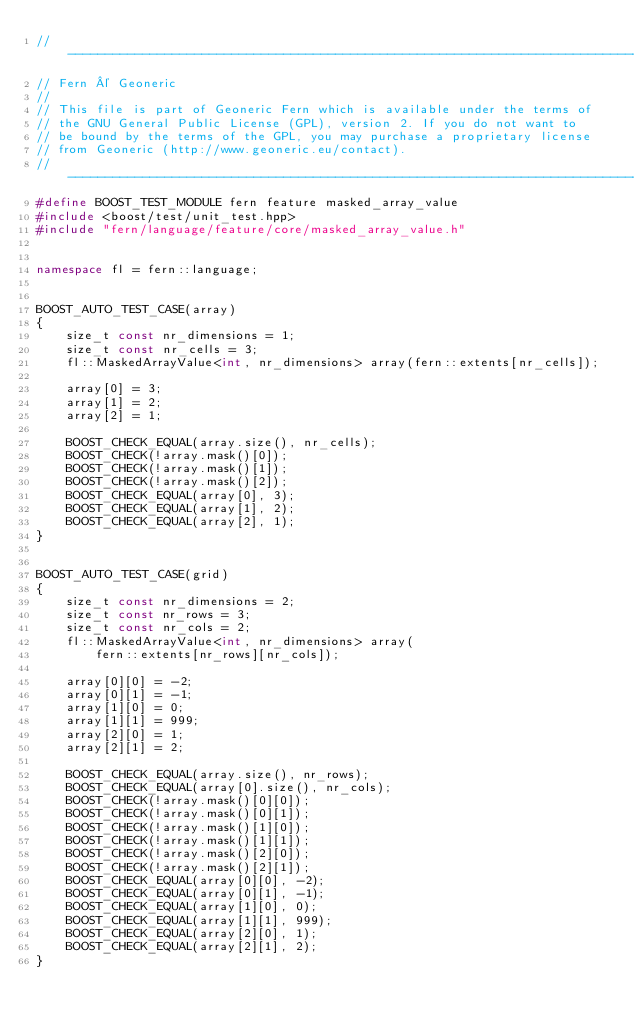<code> <loc_0><loc_0><loc_500><loc_500><_C++_>// -----------------------------------------------------------------------------
// Fern © Geoneric
//
// This file is part of Geoneric Fern which is available under the terms of
// the GNU General Public License (GPL), version 2. If you do not want to
// be bound by the terms of the GPL, you may purchase a proprietary license
// from Geoneric (http://www.geoneric.eu/contact).
// -----------------------------------------------------------------------------
#define BOOST_TEST_MODULE fern feature masked_array_value
#include <boost/test/unit_test.hpp>
#include "fern/language/feature/core/masked_array_value.h"


namespace fl = fern::language;


BOOST_AUTO_TEST_CASE(array)
{
    size_t const nr_dimensions = 1;
    size_t const nr_cells = 3;
    fl::MaskedArrayValue<int, nr_dimensions> array(fern::extents[nr_cells]);

    array[0] = 3;
    array[1] = 2;
    array[2] = 1;

    BOOST_CHECK_EQUAL(array.size(), nr_cells);
    BOOST_CHECK(!array.mask()[0]);
    BOOST_CHECK(!array.mask()[1]);
    BOOST_CHECK(!array.mask()[2]);
    BOOST_CHECK_EQUAL(array[0], 3);
    BOOST_CHECK_EQUAL(array[1], 2);
    BOOST_CHECK_EQUAL(array[2], 1);
}


BOOST_AUTO_TEST_CASE(grid)
{
    size_t const nr_dimensions = 2;
    size_t const nr_rows = 3;
    size_t const nr_cols = 2;
    fl::MaskedArrayValue<int, nr_dimensions> array(
        fern::extents[nr_rows][nr_cols]);

    array[0][0] = -2;
    array[0][1] = -1;
    array[1][0] = 0;
    array[1][1] = 999;
    array[2][0] = 1;
    array[2][1] = 2;

    BOOST_CHECK_EQUAL(array.size(), nr_rows);
    BOOST_CHECK_EQUAL(array[0].size(), nr_cols);
    BOOST_CHECK(!array.mask()[0][0]);
    BOOST_CHECK(!array.mask()[0][1]);
    BOOST_CHECK(!array.mask()[1][0]);
    BOOST_CHECK(!array.mask()[1][1]);
    BOOST_CHECK(!array.mask()[2][0]);
    BOOST_CHECK(!array.mask()[2][1]);
    BOOST_CHECK_EQUAL(array[0][0], -2);
    BOOST_CHECK_EQUAL(array[0][1], -1);
    BOOST_CHECK_EQUAL(array[1][0], 0);
    BOOST_CHECK_EQUAL(array[1][1], 999);
    BOOST_CHECK_EQUAL(array[2][0], 1);
    BOOST_CHECK_EQUAL(array[2][1], 2);
}
</code> 